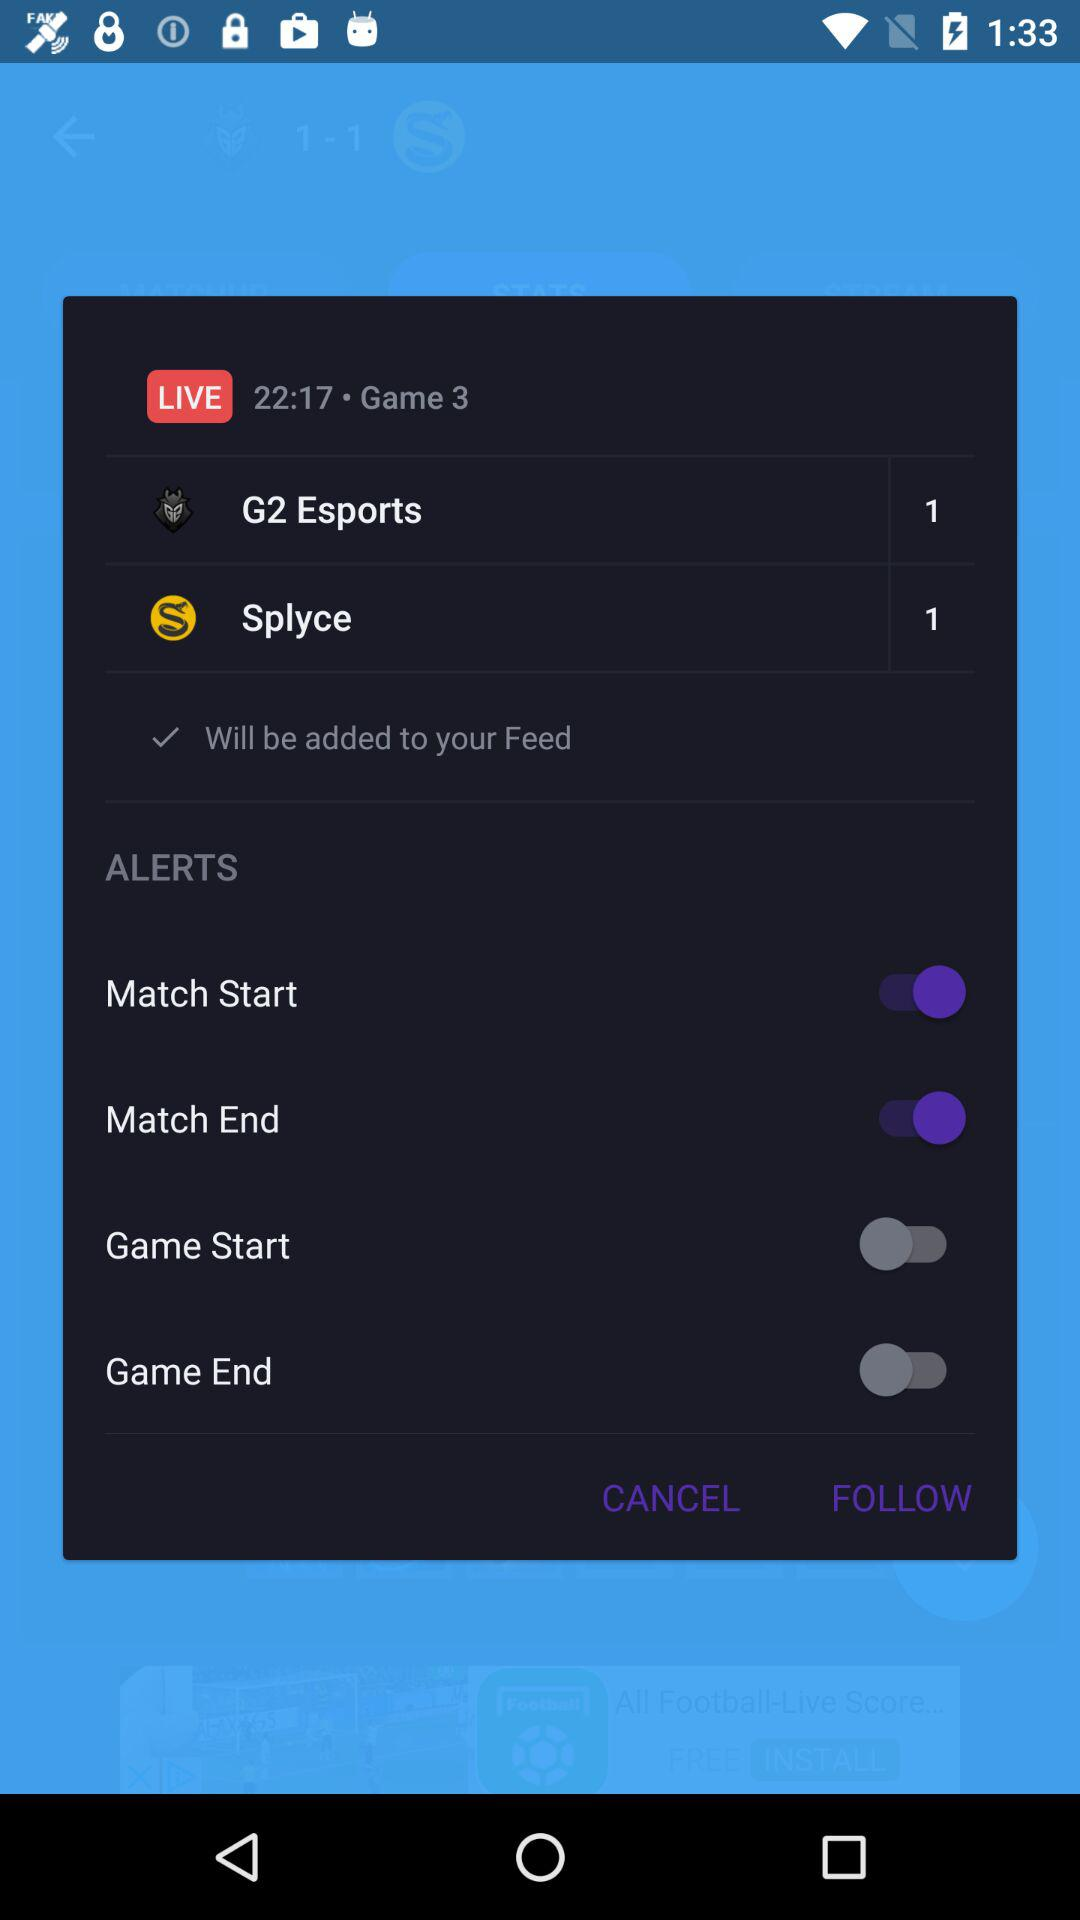What is the live match's duration? The live match's duration is 22:17. 